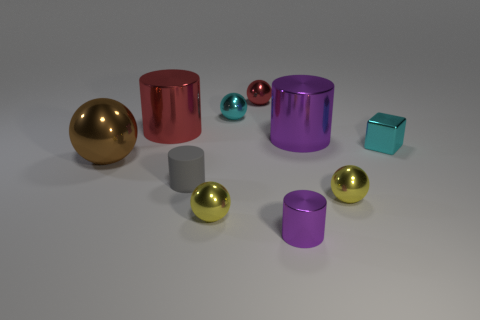How many purple cylinders must be subtracted to get 1 purple cylinders? 1 Subtract all brown metal balls. How many balls are left? 4 Subtract all blue spheres. Subtract all gray cylinders. How many spheres are left? 5 Subtract all cylinders. How many objects are left? 6 Add 1 tiny yellow metal balls. How many tiny yellow metal balls are left? 3 Add 4 gray matte things. How many gray matte things exist? 5 Subtract 0 purple cubes. How many objects are left? 10 Subtract all gray cylinders. Subtract all metallic spheres. How many objects are left? 4 